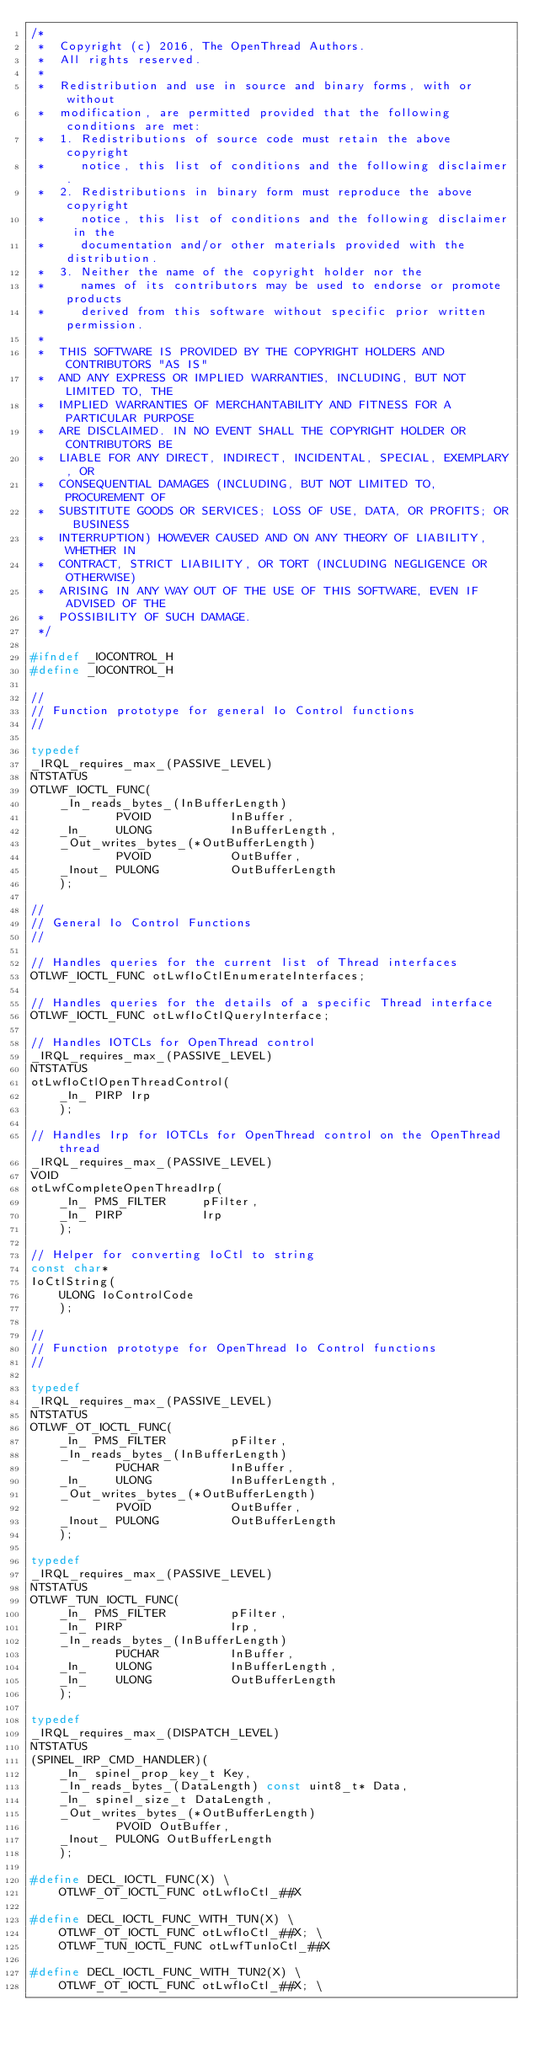Convert code to text. <code><loc_0><loc_0><loc_500><loc_500><_C_>/*
 *  Copyright (c) 2016, The OpenThread Authors.
 *  All rights reserved.
 *
 *  Redistribution and use in source and binary forms, with or without
 *  modification, are permitted provided that the following conditions are met:
 *  1. Redistributions of source code must retain the above copyright
 *     notice, this list of conditions and the following disclaimer.
 *  2. Redistributions in binary form must reproduce the above copyright
 *     notice, this list of conditions and the following disclaimer in the
 *     documentation and/or other materials provided with the distribution.
 *  3. Neither the name of the copyright holder nor the
 *     names of its contributors may be used to endorse or promote products
 *     derived from this software without specific prior written permission.
 *
 *  THIS SOFTWARE IS PROVIDED BY THE COPYRIGHT HOLDERS AND CONTRIBUTORS "AS IS"
 *  AND ANY EXPRESS OR IMPLIED WARRANTIES, INCLUDING, BUT NOT LIMITED TO, THE
 *  IMPLIED WARRANTIES OF MERCHANTABILITY AND FITNESS FOR A PARTICULAR PURPOSE
 *  ARE DISCLAIMED. IN NO EVENT SHALL THE COPYRIGHT HOLDER OR CONTRIBUTORS BE
 *  LIABLE FOR ANY DIRECT, INDIRECT, INCIDENTAL, SPECIAL, EXEMPLARY, OR
 *  CONSEQUENTIAL DAMAGES (INCLUDING, BUT NOT LIMITED TO, PROCUREMENT OF
 *  SUBSTITUTE GOODS OR SERVICES; LOSS OF USE, DATA, OR PROFITS; OR BUSINESS
 *  INTERRUPTION) HOWEVER CAUSED AND ON ANY THEORY OF LIABILITY, WHETHER IN
 *  CONTRACT, STRICT LIABILITY, OR TORT (INCLUDING NEGLIGENCE OR OTHERWISE)
 *  ARISING IN ANY WAY OUT OF THE USE OF THIS SOFTWARE, EVEN IF ADVISED OF THE
 *  POSSIBILITY OF SUCH DAMAGE.
 */

#ifndef _IOCONTROL_H
#define _IOCONTROL_H

//
// Function prototype for general Io Control functions
//

typedef 
_IRQL_requires_max_(PASSIVE_LEVEL)
NTSTATUS
OTLWF_IOCTL_FUNC(
    _In_reads_bytes_(InBufferLength)
            PVOID           InBuffer,
    _In_    ULONG           InBufferLength,
    _Out_writes_bytes_(*OutBufferLength)
            PVOID           OutBuffer,
    _Inout_ PULONG          OutBufferLength
    );

//
// General Io Control Functions
//

// Handles queries for the current list of Thread interfaces
OTLWF_IOCTL_FUNC otLwfIoCtlEnumerateInterfaces;

// Handles queries for the details of a specific Thread interface
OTLWF_IOCTL_FUNC otLwfIoCtlQueryInterface;

// Handles IOTCLs for OpenThread control
_IRQL_requires_max_(PASSIVE_LEVEL)
NTSTATUS
otLwfIoCtlOpenThreadControl(
    _In_ PIRP Irp
    );

// Handles Irp for IOTCLs for OpenThread control on the OpenThread thread
_IRQL_requires_max_(PASSIVE_LEVEL)
VOID
otLwfCompleteOpenThreadIrp(
    _In_ PMS_FILTER     pFilter,
    _In_ PIRP           Irp
    );

// Helper for converting IoCtl to string
const char*
IoCtlString(
    ULONG IoControlCode
    );

//
// Function prototype for OpenThread Io Control functions
//

typedef 
_IRQL_requires_max_(PASSIVE_LEVEL)
NTSTATUS
OTLWF_OT_IOCTL_FUNC(
    _In_ PMS_FILTER         pFilter,
    _In_reads_bytes_(InBufferLength)
            PUCHAR          InBuffer,
    _In_    ULONG           InBufferLength,
    _Out_writes_bytes_(*OutBufferLength)
            PVOID           OutBuffer,
    _Inout_ PULONG          OutBufferLength
    );

typedef 
_IRQL_requires_max_(PASSIVE_LEVEL)
NTSTATUS
OTLWF_TUN_IOCTL_FUNC(
    _In_ PMS_FILTER         pFilter,
    _In_ PIRP               Irp,
    _In_reads_bytes_(InBufferLength)
            PUCHAR          InBuffer,
    _In_    ULONG           InBufferLength,
    _In_    ULONG           OutBufferLength
    );

typedef
_IRQL_requires_max_(DISPATCH_LEVEL)
NTSTATUS
(SPINEL_IRP_CMD_HANDLER)(
    _In_ spinel_prop_key_t Key,
    _In_reads_bytes_(DataLength) const uint8_t* Data,
    _In_ spinel_size_t DataLength,
    _Out_writes_bytes_(*OutBufferLength)
            PVOID OutBuffer,
    _Inout_ PULONG OutBufferLength
    );

#define DECL_IOCTL_FUNC(X) \
    OTLWF_OT_IOCTL_FUNC otLwfIoCtl_##X

#define DECL_IOCTL_FUNC_WITH_TUN(X) \
    OTLWF_OT_IOCTL_FUNC otLwfIoCtl_##X; \
    OTLWF_TUN_IOCTL_FUNC otLwfTunIoCtl_##X

#define DECL_IOCTL_FUNC_WITH_TUN2(X) \
    OTLWF_OT_IOCTL_FUNC otLwfIoCtl_##X; \</code> 